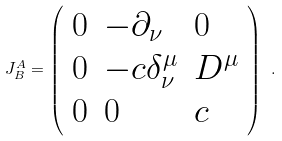Convert formula to latex. <formula><loc_0><loc_0><loc_500><loc_500>J _ { B } ^ { A } = \left ( \begin{array} { l l l } { 0 } & { { - \partial _ { \nu } } } & { 0 } \\ { 0 } & { { - c \delta _ { \nu } ^ { \mu } } } & { { D ^ { \mu } } } \\ { 0 } & { 0 } & { c } \end{array} \right ) \ .</formula> 